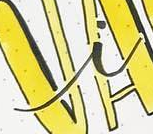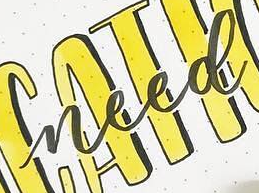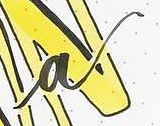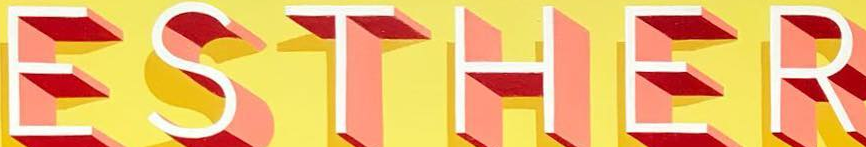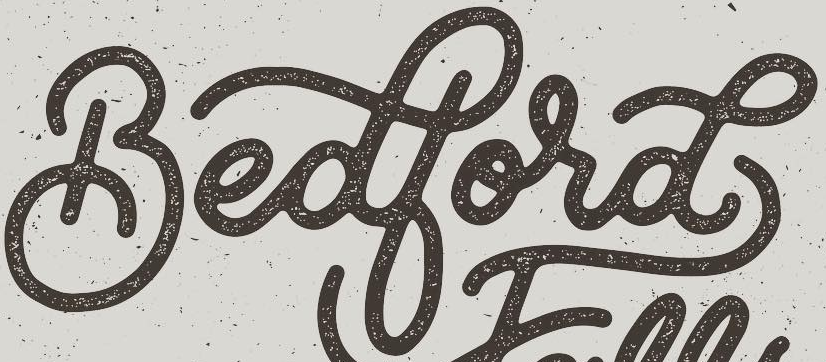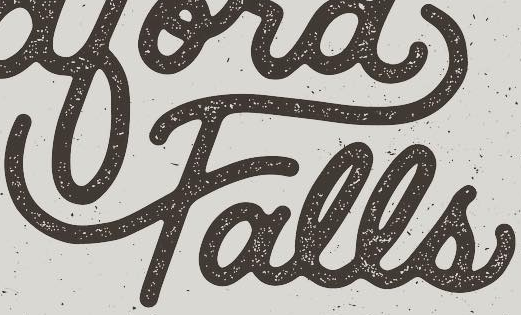Read the text from these images in sequence, separated by a semicolon. i; need; a; ESTHER; Bedbord; Falls 